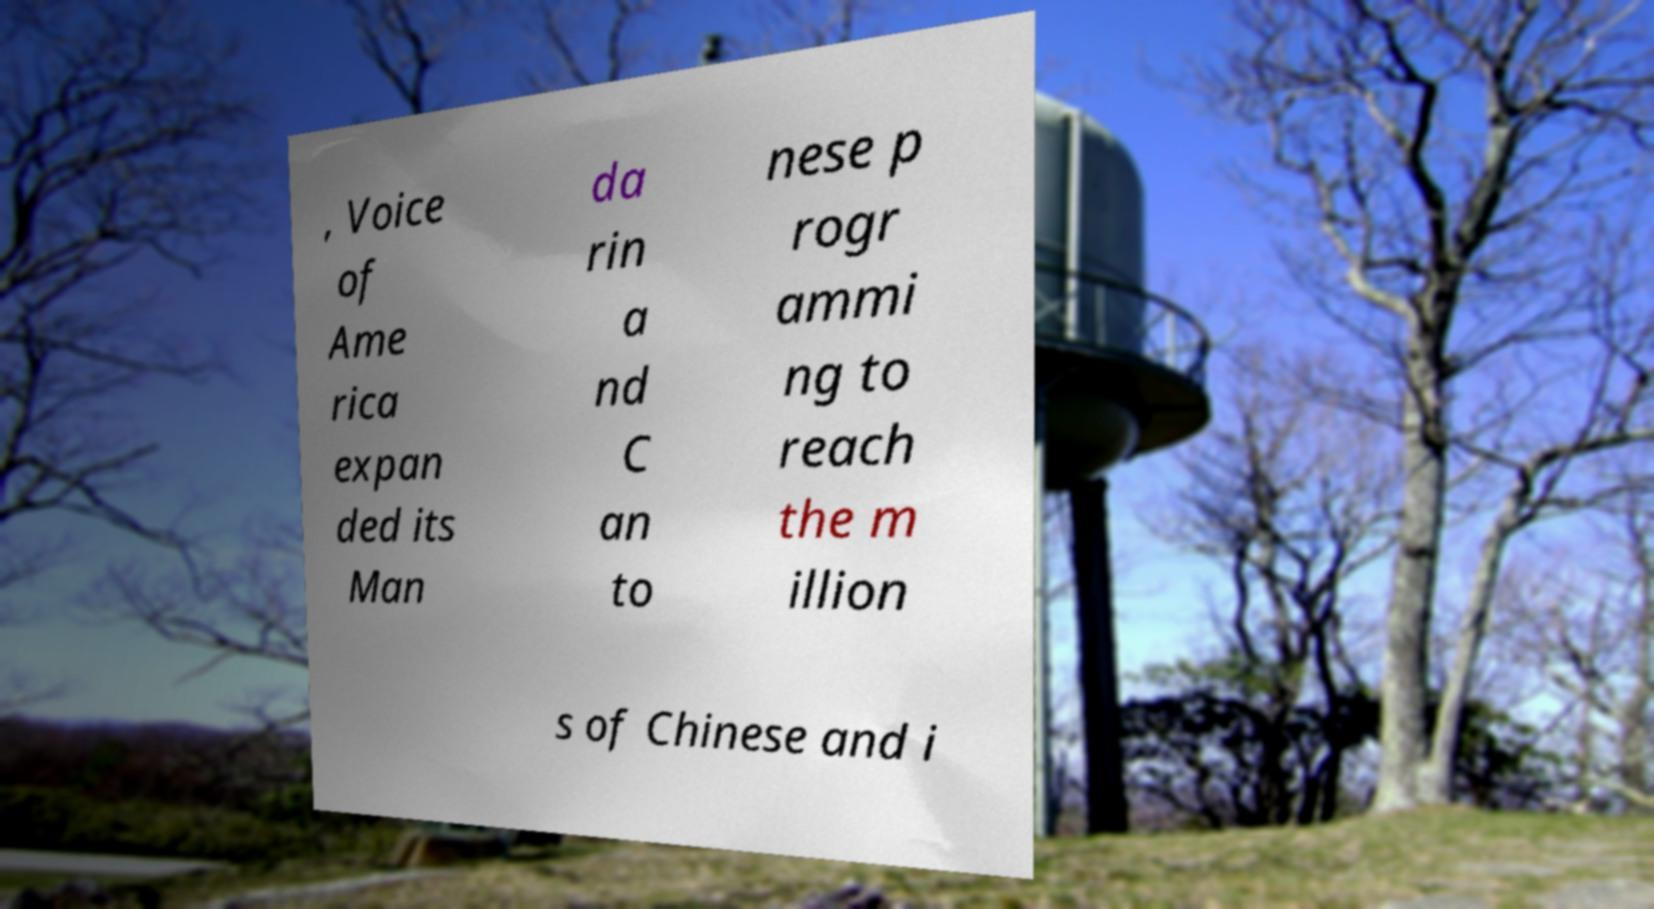Please read and relay the text visible in this image. What does it say? , Voice of Ame rica expan ded its Man da rin a nd C an to nese p rogr ammi ng to reach the m illion s of Chinese and i 